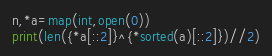<code> <loc_0><loc_0><loc_500><loc_500><_Cython_>n,*a=map(int,open(0))
print(len({*a[::2]}^{*sorted(a)[::2]})//2)</code> 